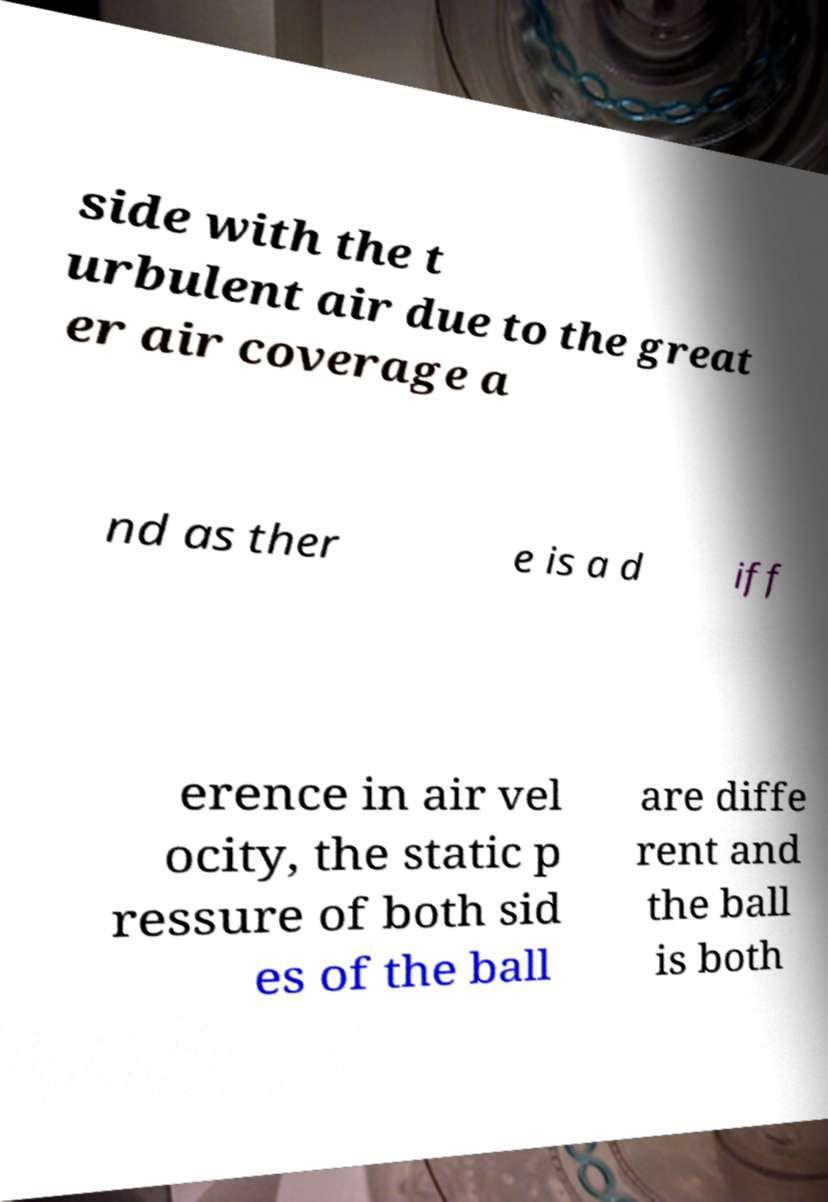Can you accurately transcribe the text from the provided image for me? side with the t urbulent air due to the great er air coverage a nd as ther e is a d iff erence in air vel ocity, the static p ressure of both sid es of the ball are diffe rent and the ball is both 